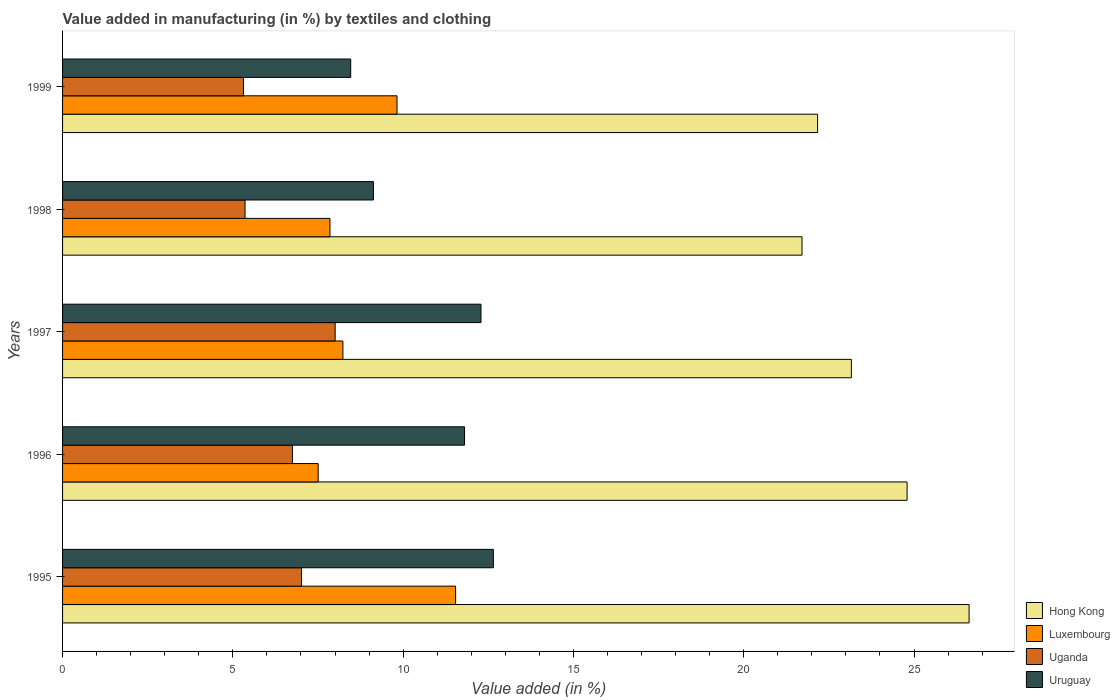How many different coloured bars are there?
Give a very brief answer. 4. Are the number of bars per tick equal to the number of legend labels?
Your answer should be compact. Yes. How many bars are there on the 1st tick from the bottom?
Provide a short and direct response. 4. What is the percentage of value added in manufacturing by textiles and clothing in Hong Kong in 1995?
Your response must be concise. 26.62. Across all years, what is the maximum percentage of value added in manufacturing by textiles and clothing in Uganda?
Make the answer very short. 8. Across all years, what is the minimum percentage of value added in manufacturing by textiles and clothing in Hong Kong?
Keep it short and to the point. 21.71. What is the total percentage of value added in manufacturing by textiles and clothing in Uruguay in the graph?
Offer a very short reply. 54.32. What is the difference between the percentage of value added in manufacturing by textiles and clothing in Uruguay in 1998 and that in 1999?
Provide a succinct answer. 0.67. What is the difference between the percentage of value added in manufacturing by textiles and clothing in Uganda in 1995 and the percentage of value added in manufacturing by textiles and clothing in Uruguay in 1999?
Provide a succinct answer. -1.45. What is the average percentage of value added in manufacturing by textiles and clothing in Uganda per year?
Offer a terse response. 6.49. In the year 1997, what is the difference between the percentage of value added in manufacturing by textiles and clothing in Uruguay and percentage of value added in manufacturing by textiles and clothing in Uganda?
Make the answer very short. 4.28. In how many years, is the percentage of value added in manufacturing by textiles and clothing in Uganda greater than 11 %?
Provide a short and direct response. 0. What is the ratio of the percentage of value added in manufacturing by textiles and clothing in Uganda in 1997 to that in 1998?
Ensure brevity in your answer.  1.49. Is the percentage of value added in manufacturing by textiles and clothing in Hong Kong in 1997 less than that in 1998?
Your answer should be very brief. No. Is the difference between the percentage of value added in manufacturing by textiles and clothing in Uruguay in 1998 and 1999 greater than the difference between the percentage of value added in manufacturing by textiles and clothing in Uganda in 1998 and 1999?
Give a very brief answer. Yes. What is the difference between the highest and the second highest percentage of value added in manufacturing by textiles and clothing in Luxembourg?
Your response must be concise. 1.72. What is the difference between the highest and the lowest percentage of value added in manufacturing by textiles and clothing in Uruguay?
Offer a terse response. 4.19. In how many years, is the percentage of value added in manufacturing by textiles and clothing in Uruguay greater than the average percentage of value added in manufacturing by textiles and clothing in Uruguay taken over all years?
Your answer should be compact. 3. Is it the case that in every year, the sum of the percentage of value added in manufacturing by textiles and clothing in Uruguay and percentage of value added in manufacturing by textiles and clothing in Luxembourg is greater than the sum of percentage of value added in manufacturing by textiles and clothing in Hong Kong and percentage of value added in manufacturing by textiles and clothing in Uganda?
Your answer should be very brief. Yes. What does the 3rd bar from the top in 1999 represents?
Ensure brevity in your answer.  Luxembourg. What does the 2nd bar from the bottom in 1999 represents?
Keep it short and to the point. Luxembourg. Is it the case that in every year, the sum of the percentage of value added in manufacturing by textiles and clothing in Hong Kong and percentage of value added in manufacturing by textiles and clothing in Uruguay is greater than the percentage of value added in manufacturing by textiles and clothing in Luxembourg?
Your response must be concise. Yes. How many years are there in the graph?
Offer a terse response. 5. Are the values on the major ticks of X-axis written in scientific E-notation?
Make the answer very short. No. Does the graph contain any zero values?
Offer a very short reply. No. Does the graph contain grids?
Your response must be concise. No. Where does the legend appear in the graph?
Make the answer very short. Bottom right. How many legend labels are there?
Provide a succinct answer. 4. What is the title of the graph?
Make the answer very short. Value added in manufacturing (in %) by textiles and clothing. Does "Austria" appear as one of the legend labels in the graph?
Your response must be concise. No. What is the label or title of the X-axis?
Provide a short and direct response. Value added (in %). What is the Value added (in %) in Hong Kong in 1995?
Your answer should be very brief. 26.62. What is the Value added (in %) in Luxembourg in 1995?
Provide a succinct answer. 11.54. What is the Value added (in %) of Uganda in 1995?
Your answer should be compact. 7.02. What is the Value added (in %) in Uruguay in 1995?
Provide a short and direct response. 12.65. What is the Value added (in %) of Hong Kong in 1996?
Offer a terse response. 24.8. What is the Value added (in %) in Luxembourg in 1996?
Offer a very short reply. 7.51. What is the Value added (in %) in Uganda in 1996?
Make the answer very short. 6.75. What is the Value added (in %) in Uruguay in 1996?
Offer a very short reply. 11.8. What is the Value added (in %) in Hong Kong in 1997?
Offer a terse response. 23.16. What is the Value added (in %) in Luxembourg in 1997?
Your response must be concise. 8.23. What is the Value added (in %) of Uganda in 1997?
Your response must be concise. 8. What is the Value added (in %) of Uruguay in 1997?
Your answer should be compact. 12.29. What is the Value added (in %) in Hong Kong in 1998?
Keep it short and to the point. 21.71. What is the Value added (in %) in Luxembourg in 1998?
Ensure brevity in your answer.  7.85. What is the Value added (in %) in Uganda in 1998?
Offer a very short reply. 5.36. What is the Value added (in %) in Uruguay in 1998?
Keep it short and to the point. 9.13. What is the Value added (in %) in Hong Kong in 1999?
Your answer should be compact. 22.17. What is the Value added (in %) of Luxembourg in 1999?
Offer a very short reply. 9.82. What is the Value added (in %) in Uganda in 1999?
Make the answer very short. 5.31. What is the Value added (in %) of Uruguay in 1999?
Make the answer very short. 8.46. Across all years, what is the maximum Value added (in %) in Hong Kong?
Offer a terse response. 26.62. Across all years, what is the maximum Value added (in %) of Luxembourg?
Give a very brief answer. 11.54. Across all years, what is the maximum Value added (in %) in Uganda?
Make the answer very short. 8. Across all years, what is the maximum Value added (in %) of Uruguay?
Offer a very short reply. 12.65. Across all years, what is the minimum Value added (in %) of Hong Kong?
Ensure brevity in your answer.  21.71. Across all years, what is the minimum Value added (in %) in Luxembourg?
Provide a succinct answer. 7.51. Across all years, what is the minimum Value added (in %) of Uganda?
Your answer should be very brief. 5.31. Across all years, what is the minimum Value added (in %) of Uruguay?
Ensure brevity in your answer.  8.46. What is the total Value added (in %) in Hong Kong in the graph?
Keep it short and to the point. 118.45. What is the total Value added (in %) in Luxembourg in the graph?
Your answer should be compact. 44.95. What is the total Value added (in %) in Uganda in the graph?
Provide a succinct answer. 32.44. What is the total Value added (in %) in Uruguay in the graph?
Provide a succinct answer. 54.32. What is the difference between the Value added (in %) in Hong Kong in 1995 and that in 1996?
Give a very brief answer. 1.82. What is the difference between the Value added (in %) of Luxembourg in 1995 and that in 1996?
Give a very brief answer. 4.03. What is the difference between the Value added (in %) of Uganda in 1995 and that in 1996?
Your answer should be compact. 0.27. What is the difference between the Value added (in %) of Uruguay in 1995 and that in 1996?
Keep it short and to the point. 0.85. What is the difference between the Value added (in %) in Hong Kong in 1995 and that in 1997?
Offer a terse response. 3.46. What is the difference between the Value added (in %) of Luxembourg in 1995 and that in 1997?
Offer a terse response. 3.31. What is the difference between the Value added (in %) of Uganda in 1995 and that in 1997?
Ensure brevity in your answer.  -0.99. What is the difference between the Value added (in %) of Uruguay in 1995 and that in 1997?
Your answer should be very brief. 0.36. What is the difference between the Value added (in %) of Hong Kong in 1995 and that in 1998?
Your response must be concise. 4.91. What is the difference between the Value added (in %) of Luxembourg in 1995 and that in 1998?
Give a very brief answer. 3.69. What is the difference between the Value added (in %) of Uganda in 1995 and that in 1998?
Offer a very short reply. 1.66. What is the difference between the Value added (in %) of Uruguay in 1995 and that in 1998?
Give a very brief answer. 3.52. What is the difference between the Value added (in %) in Hong Kong in 1995 and that in 1999?
Ensure brevity in your answer.  4.45. What is the difference between the Value added (in %) in Luxembourg in 1995 and that in 1999?
Ensure brevity in your answer.  1.72. What is the difference between the Value added (in %) of Uganda in 1995 and that in 1999?
Your answer should be very brief. 1.7. What is the difference between the Value added (in %) of Uruguay in 1995 and that in 1999?
Provide a short and direct response. 4.19. What is the difference between the Value added (in %) of Hong Kong in 1996 and that in 1997?
Offer a very short reply. 1.64. What is the difference between the Value added (in %) of Luxembourg in 1996 and that in 1997?
Offer a terse response. -0.73. What is the difference between the Value added (in %) of Uganda in 1996 and that in 1997?
Your response must be concise. -1.25. What is the difference between the Value added (in %) in Uruguay in 1996 and that in 1997?
Provide a short and direct response. -0.48. What is the difference between the Value added (in %) of Hong Kong in 1996 and that in 1998?
Give a very brief answer. 3.08. What is the difference between the Value added (in %) of Luxembourg in 1996 and that in 1998?
Offer a very short reply. -0.35. What is the difference between the Value added (in %) in Uganda in 1996 and that in 1998?
Your answer should be compact. 1.39. What is the difference between the Value added (in %) of Uruguay in 1996 and that in 1998?
Provide a succinct answer. 2.68. What is the difference between the Value added (in %) in Hong Kong in 1996 and that in 1999?
Provide a succinct answer. 2.63. What is the difference between the Value added (in %) in Luxembourg in 1996 and that in 1999?
Make the answer very short. -2.31. What is the difference between the Value added (in %) in Uganda in 1996 and that in 1999?
Your response must be concise. 1.44. What is the difference between the Value added (in %) of Uruguay in 1996 and that in 1999?
Offer a terse response. 3.34. What is the difference between the Value added (in %) of Hong Kong in 1997 and that in 1998?
Provide a succinct answer. 1.45. What is the difference between the Value added (in %) of Luxembourg in 1997 and that in 1998?
Your response must be concise. 0.38. What is the difference between the Value added (in %) in Uganda in 1997 and that in 1998?
Keep it short and to the point. 2.65. What is the difference between the Value added (in %) in Uruguay in 1997 and that in 1998?
Your answer should be very brief. 3.16. What is the difference between the Value added (in %) of Luxembourg in 1997 and that in 1999?
Provide a succinct answer. -1.59. What is the difference between the Value added (in %) in Uganda in 1997 and that in 1999?
Ensure brevity in your answer.  2.69. What is the difference between the Value added (in %) of Uruguay in 1997 and that in 1999?
Your response must be concise. 3.83. What is the difference between the Value added (in %) of Hong Kong in 1998 and that in 1999?
Give a very brief answer. -0.46. What is the difference between the Value added (in %) of Luxembourg in 1998 and that in 1999?
Keep it short and to the point. -1.97. What is the difference between the Value added (in %) in Uganda in 1998 and that in 1999?
Provide a succinct answer. 0.05. What is the difference between the Value added (in %) of Uruguay in 1998 and that in 1999?
Make the answer very short. 0.67. What is the difference between the Value added (in %) of Hong Kong in 1995 and the Value added (in %) of Luxembourg in 1996?
Provide a short and direct response. 19.11. What is the difference between the Value added (in %) of Hong Kong in 1995 and the Value added (in %) of Uganda in 1996?
Your answer should be compact. 19.87. What is the difference between the Value added (in %) in Hong Kong in 1995 and the Value added (in %) in Uruguay in 1996?
Your response must be concise. 14.81. What is the difference between the Value added (in %) in Luxembourg in 1995 and the Value added (in %) in Uganda in 1996?
Your answer should be very brief. 4.79. What is the difference between the Value added (in %) in Luxembourg in 1995 and the Value added (in %) in Uruguay in 1996?
Your response must be concise. -0.26. What is the difference between the Value added (in %) of Uganda in 1995 and the Value added (in %) of Uruguay in 1996?
Your response must be concise. -4.79. What is the difference between the Value added (in %) of Hong Kong in 1995 and the Value added (in %) of Luxembourg in 1997?
Offer a terse response. 18.39. What is the difference between the Value added (in %) in Hong Kong in 1995 and the Value added (in %) in Uganda in 1997?
Ensure brevity in your answer.  18.61. What is the difference between the Value added (in %) of Hong Kong in 1995 and the Value added (in %) of Uruguay in 1997?
Your answer should be compact. 14.33. What is the difference between the Value added (in %) of Luxembourg in 1995 and the Value added (in %) of Uganda in 1997?
Provide a short and direct response. 3.54. What is the difference between the Value added (in %) in Luxembourg in 1995 and the Value added (in %) in Uruguay in 1997?
Provide a succinct answer. -0.75. What is the difference between the Value added (in %) of Uganda in 1995 and the Value added (in %) of Uruguay in 1997?
Offer a very short reply. -5.27. What is the difference between the Value added (in %) of Hong Kong in 1995 and the Value added (in %) of Luxembourg in 1998?
Your answer should be compact. 18.77. What is the difference between the Value added (in %) in Hong Kong in 1995 and the Value added (in %) in Uganda in 1998?
Your response must be concise. 21.26. What is the difference between the Value added (in %) in Hong Kong in 1995 and the Value added (in %) in Uruguay in 1998?
Give a very brief answer. 17.49. What is the difference between the Value added (in %) in Luxembourg in 1995 and the Value added (in %) in Uganda in 1998?
Offer a very short reply. 6.18. What is the difference between the Value added (in %) in Luxembourg in 1995 and the Value added (in %) in Uruguay in 1998?
Your answer should be compact. 2.41. What is the difference between the Value added (in %) of Uganda in 1995 and the Value added (in %) of Uruguay in 1998?
Your answer should be compact. -2.11. What is the difference between the Value added (in %) of Hong Kong in 1995 and the Value added (in %) of Luxembourg in 1999?
Make the answer very short. 16.8. What is the difference between the Value added (in %) in Hong Kong in 1995 and the Value added (in %) in Uganda in 1999?
Provide a succinct answer. 21.3. What is the difference between the Value added (in %) of Hong Kong in 1995 and the Value added (in %) of Uruguay in 1999?
Ensure brevity in your answer.  18.16. What is the difference between the Value added (in %) of Luxembourg in 1995 and the Value added (in %) of Uganda in 1999?
Provide a short and direct response. 6.23. What is the difference between the Value added (in %) of Luxembourg in 1995 and the Value added (in %) of Uruguay in 1999?
Give a very brief answer. 3.08. What is the difference between the Value added (in %) of Uganda in 1995 and the Value added (in %) of Uruguay in 1999?
Make the answer very short. -1.45. What is the difference between the Value added (in %) in Hong Kong in 1996 and the Value added (in %) in Luxembourg in 1997?
Provide a succinct answer. 16.56. What is the difference between the Value added (in %) in Hong Kong in 1996 and the Value added (in %) in Uganda in 1997?
Provide a short and direct response. 16.79. What is the difference between the Value added (in %) of Hong Kong in 1996 and the Value added (in %) of Uruguay in 1997?
Keep it short and to the point. 12.51. What is the difference between the Value added (in %) in Luxembourg in 1996 and the Value added (in %) in Uganda in 1997?
Offer a very short reply. -0.5. What is the difference between the Value added (in %) in Luxembourg in 1996 and the Value added (in %) in Uruguay in 1997?
Offer a very short reply. -4.78. What is the difference between the Value added (in %) in Uganda in 1996 and the Value added (in %) in Uruguay in 1997?
Your answer should be very brief. -5.54. What is the difference between the Value added (in %) in Hong Kong in 1996 and the Value added (in %) in Luxembourg in 1998?
Your response must be concise. 16.94. What is the difference between the Value added (in %) of Hong Kong in 1996 and the Value added (in %) of Uganda in 1998?
Your answer should be compact. 19.44. What is the difference between the Value added (in %) in Hong Kong in 1996 and the Value added (in %) in Uruguay in 1998?
Offer a very short reply. 15.67. What is the difference between the Value added (in %) in Luxembourg in 1996 and the Value added (in %) in Uganda in 1998?
Give a very brief answer. 2.15. What is the difference between the Value added (in %) in Luxembourg in 1996 and the Value added (in %) in Uruguay in 1998?
Your response must be concise. -1.62. What is the difference between the Value added (in %) in Uganda in 1996 and the Value added (in %) in Uruguay in 1998?
Your response must be concise. -2.38. What is the difference between the Value added (in %) in Hong Kong in 1996 and the Value added (in %) in Luxembourg in 1999?
Offer a terse response. 14.98. What is the difference between the Value added (in %) of Hong Kong in 1996 and the Value added (in %) of Uganda in 1999?
Your answer should be very brief. 19.48. What is the difference between the Value added (in %) in Hong Kong in 1996 and the Value added (in %) in Uruguay in 1999?
Keep it short and to the point. 16.34. What is the difference between the Value added (in %) in Luxembourg in 1996 and the Value added (in %) in Uganda in 1999?
Offer a terse response. 2.19. What is the difference between the Value added (in %) of Luxembourg in 1996 and the Value added (in %) of Uruguay in 1999?
Your response must be concise. -0.95. What is the difference between the Value added (in %) of Uganda in 1996 and the Value added (in %) of Uruguay in 1999?
Keep it short and to the point. -1.71. What is the difference between the Value added (in %) of Hong Kong in 1997 and the Value added (in %) of Luxembourg in 1998?
Your response must be concise. 15.31. What is the difference between the Value added (in %) in Hong Kong in 1997 and the Value added (in %) in Uganda in 1998?
Your response must be concise. 17.8. What is the difference between the Value added (in %) in Hong Kong in 1997 and the Value added (in %) in Uruguay in 1998?
Your answer should be compact. 14.03. What is the difference between the Value added (in %) in Luxembourg in 1997 and the Value added (in %) in Uganda in 1998?
Give a very brief answer. 2.87. What is the difference between the Value added (in %) in Luxembourg in 1997 and the Value added (in %) in Uruguay in 1998?
Ensure brevity in your answer.  -0.9. What is the difference between the Value added (in %) of Uganda in 1997 and the Value added (in %) of Uruguay in 1998?
Give a very brief answer. -1.12. What is the difference between the Value added (in %) in Hong Kong in 1997 and the Value added (in %) in Luxembourg in 1999?
Your answer should be compact. 13.34. What is the difference between the Value added (in %) of Hong Kong in 1997 and the Value added (in %) of Uganda in 1999?
Provide a short and direct response. 17.85. What is the difference between the Value added (in %) of Hong Kong in 1997 and the Value added (in %) of Uruguay in 1999?
Your response must be concise. 14.7. What is the difference between the Value added (in %) of Luxembourg in 1997 and the Value added (in %) of Uganda in 1999?
Provide a short and direct response. 2.92. What is the difference between the Value added (in %) in Luxembourg in 1997 and the Value added (in %) in Uruguay in 1999?
Give a very brief answer. -0.23. What is the difference between the Value added (in %) of Uganda in 1997 and the Value added (in %) of Uruguay in 1999?
Your response must be concise. -0.46. What is the difference between the Value added (in %) in Hong Kong in 1998 and the Value added (in %) in Luxembourg in 1999?
Your answer should be very brief. 11.89. What is the difference between the Value added (in %) in Hong Kong in 1998 and the Value added (in %) in Uganda in 1999?
Your answer should be very brief. 16.4. What is the difference between the Value added (in %) of Hong Kong in 1998 and the Value added (in %) of Uruguay in 1999?
Your response must be concise. 13.25. What is the difference between the Value added (in %) in Luxembourg in 1998 and the Value added (in %) in Uganda in 1999?
Offer a very short reply. 2.54. What is the difference between the Value added (in %) in Luxembourg in 1998 and the Value added (in %) in Uruguay in 1999?
Your response must be concise. -0.61. What is the difference between the Value added (in %) in Uganda in 1998 and the Value added (in %) in Uruguay in 1999?
Your answer should be very brief. -3.1. What is the average Value added (in %) of Hong Kong per year?
Your answer should be compact. 23.69. What is the average Value added (in %) of Luxembourg per year?
Ensure brevity in your answer.  8.99. What is the average Value added (in %) of Uganda per year?
Offer a terse response. 6.49. What is the average Value added (in %) of Uruguay per year?
Make the answer very short. 10.86. In the year 1995, what is the difference between the Value added (in %) in Hong Kong and Value added (in %) in Luxembourg?
Offer a very short reply. 15.08. In the year 1995, what is the difference between the Value added (in %) of Hong Kong and Value added (in %) of Uganda?
Provide a short and direct response. 19.6. In the year 1995, what is the difference between the Value added (in %) in Hong Kong and Value added (in %) in Uruguay?
Keep it short and to the point. 13.97. In the year 1995, what is the difference between the Value added (in %) in Luxembourg and Value added (in %) in Uganda?
Your answer should be compact. 4.52. In the year 1995, what is the difference between the Value added (in %) of Luxembourg and Value added (in %) of Uruguay?
Keep it short and to the point. -1.11. In the year 1995, what is the difference between the Value added (in %) in Uganda and Value added (in %) in Uruguay?
Offer a terse response. -5.63. In the year 1996, what is the difference between the Value added (in %) in Hong Kong and Value added (in %) in Luxembourg?
Give a very brief answer. 17.29. In the year 1996, what is the difference between the Value added (in %) in Hong Kong and Value added (in %) in Uganda?
Your response must be concise. 18.05. In the year 1996, what is the difference between the Value added (in %) of Hong Kong and Value added (in %) of Uruguay?
Your answer should be very brief. 12.99. In the year 1996, what is the difference between the Value added (in %) in Luxembourg and Value added (in %) in Uganda?
Your response must be concise. 0.76. In the year 1996, what is the difference between the Value added (in %) in Luxembourg and Value added (in %) in Uruguay?
Ensure brevity in your answer.  -4.3. In the year 1996, what is the difference between the Value added (in %) in Uganda and Value added (in %) in Uruguay?
Offer a very short reply. -5.05. In the year 1997, what is the difference between the Value added (in %) in Hong Kong and Value added (in %) in Luxembourg?
Your answer should be very brief. 14.93. In the year 1997, what is the difference between the Value added (in %) of Hong Kong and Value added (in %) of Uganda?
Offer a very short reply. 15.16. In the year 1997, what is the difference between the Value added (in %) of Hong Kong and Value added (in %) of Uruguay?
Your answer should be compact. 10.87. In the year 1997, what is the difference between the Value added (in %) in Luxembourg and Value added (in %) in Uganda?
Offer a terse response. 0.23. In the year 1997, what is the difference between the Value added (in %) in Luxembourg and Value added (in %) in Uruguay?
Keep it short and to the point. -4.05. In the year 1997, what is the difference between the Value added (in %) of Uganda and Value added (in %) of Uruguay?
Give a very brief answer. -4.28. In the year 1998, what is the difference between the Value added (in %) of Hong Kong and Value added (in %) of Luxembourg?
Your response must be concise. 13.86. In the year 1998, what is the difference between the Value added (in %) of Hong Kong and Value added (in %) of Uganda?
Offer a terse response. 16.35. In the year 1998, what is the difference between the Value added (in %) in Hong Kong and Value added (in %) in Uruguay?
Ensure brevity in your answer.  12.58. In the year 1998, what is the difference between the Value added (in %) in Luxembourg and Value added (in %) in Uganda?
Offer a terse response. 2.49. In the year 1998, what is the difference between the Value added (in %) in Luxembourg and Value added (in %) in Uruguay?
Offer a very short reply. -1.28. In the year 1998, what is the difference between the Value added (in %) of Uganda and Value added (in %) of Uruguay?
Provide a short and direct response. -3.77. In the year 1999, what is the difference between the Value added (in %) of Hong Kong and Value added (in %) of Luxembourg?
Ensure brevity in your answer.  12.35. In the year 1999, what is the difference between the Value added (in %) of Hong Kong and Value added (in %) of Uganda?
Ensure brevity in your answer.  16.86. In the year 1999, what is the difference between the Value added (in %) in Hong Kong and Value added (in %) in Uruguay?
Offer a terse response. 13.71. In the year 1999, what is the difference between the Value added (in %) in Luxembourg and Value added (in %) in Uganda?
Provide a succinct answer. 4.51. In the year 1999, what is the difference between the Value added (in %) in Luxembourg and Value added (in %) in Uruguay?
Give a very brief answer. 1.36. In the year 1999, what is the difference between the Value added (in %) in Uganda and Value added (in %) in Uruguay?
Offer a terse response. -3.15. What is the ratio of the Value added (in %) in Hong Kong in 1995 to that in 1996?
Give a very brief answer. 1.07. What is the ratio of the Value added (in %) in Luxembourg in 1995 to that in 1996?
Provide a succinct answer. 1.54. What is the ratio of the Value added (in %) in Uganda in 1995 to that in 1996?
Provide a short and direct response. 1.04. What is the ratio of the Value added (in %) in Uruguay in 1995 to that in 1996?
Offer a terse response. 1.07. What is the ratio of the Value added (in %) of Hong Kong in 1995 to that in 1997?
Offer a terse response. 1.15. What is the ratio of the Value added (in %) in Luxembourg in 1995 to that in 1997?
Give a very brief answer. 1.4. What is the ratio of the Value added (in %) of Uganda in 1995 to that in 1997?
Provide a short and direct response. 0.88. What is the ratio of the Value added (in %) of Uruguay in 1995 to that in 1997?
Ensure brevity in your answer.  1.03. What is the ratio of the Value added (in %) of Hong Kong in 1995 to that in 1998?
Provide a short and direct response. 1.23. What is the ratio of the Value added (in %) in Luxembourg in 1995 to that in 1998?
Provide a short and direct response. 1.47. What is the ratio of the Value added (in %) of Uganda in 1995 to that in 1998?
Offer a terse response. 1.31. What is the ratio of the Value added (in %) of Uruguay in 1995 to that in 1998?
Provide a short and direct response. 1.39. What is the ratio of the Value added (in %) of Hong Kong in 1995 to that in 1999?
Make the answer very short. 1.2. What is the ratio of the Value added (in %) of Luxembourg in 1995 to that in 1999?
Give a very brief answer. 1.18. What is the ratio of the Value added (in %) in Uganda in 1995 to that in 1999?
Your response must be concise. 1.32. What is the ratio of the Value added (in %) in Uruguay in 1995 to that in 1999?
Offer a terse response. 1.5. What is the ratio of the Value added (in %) in Hong Kong in 1996 to that in 1997?
Your answer should be compact. 1.07. What is the ratio of the Value added (in %) of Luxembourg in 1996 to that in 1997?
Provide a succinct answer. 0.91. What is the ratio of the Value added (in %) of Uganda in 1996 to that in 1997?
Offer a terse response. 0.84. What is the ratio of the Value added (in %) in Uruguay in 1996 to that in 1997?
Provide a short and direct response. 0.96. What is the ratio of the Value added (in %) of Hong Kong in 1996 to that in 1998?
Your answer should be very brief. 1.14. What is the ratio of the Value added (in %) in Luxembourg in 1996 to that in 1998?
Make the answer very short. 0.96. What is the ratio of the Value added (in %) of Uganda in 1996 to that in 1998?
Your response must be concise. 1.26. What is the ratio of the Value added (in %) of Uruguay in 1996 to that in 1998?
Your response must be concise. 1.29. What is the ratio of the Value added (in %) in Hong Kong in 1996 to that in 1999?
Offer a terse response. 1.12. What is the ratio of the Value added (in %) in Luxembourg in 1996 to that in 1999?
Ensure brevity in your answer.  0.76. What is the ratio of the Value added (in %) of Uganda in 1996 to that in 1999?
Keep it short and to the point. 1.27. What is the ratio of the Value added (in %) of Uruguay in 1996 to that in 1999?
Offer a terse response. 1.4. What is the ratio of the Value added (in %) of Hong Kong in 1997 to that in 1998?
Provide a succinct answer. 1.07. What is the ratio of the Value added (in %) in Luxembourg in 1997 to that in 1998?
Give a very brief answer. 1.05. What is the ratio of the Value added (in %) in Uganda in 1997 to that in 1998?
Make the answer very short. 1.49. What is the ratio of the Value added (in %) in Uruguay in 1997 to that in 1998?
Your answer should be very brief. 1.35. What is the ratio of the Value added (in %) in Hong Kong in 1997 to that in 1999?
Offer a very short reply. 1.04. What is the ratio of the Value added (in %) of Luxembourg in 1997 to that in 1999?
Your answer should be compact. 0.84. What is the ratio of the Value added (in %) in Uganda in 1997 to that in 1999?
Offer a terse response. 1.51. What is the ratio of the Value added (in %) in Uruguay in 1997 to that in 1999?
Your answer should be compact. 1.45. What is the ratio of the Value added (in %) in Hong Kong in 1998 to that in 1999?
Provide a short and direct response. 0.98. What is the ratio of the Value added (in %) of Luxembourg in 1998 to that in 1999?
Ensure brevity in your answer.  0.8. What is the ratio of the Value added (in %) in Uganda in 1998 to that in 1999?
Offer a very short reply. 1.01. What is the ratio of the Value added (in %) in Uruguay in 1998 to that in 1999?
Your answer should be compact. 1.08. What is the difference between the highest and the second highest Value added (in %) in Hong Kong?
Offer a very short reply. 1.82. What is the difference between the highest and the second highest Value added (in %) in Luxembourg?
Keep it short and to the point. 1.72. What is the difference between the highest and the second highest Value added (in %) of Uruguay?
Keep it short and to the point. 0.36. What is the difference between the highest and the lowest Value added (in %) in Hong Kong?
Give a very brief answer. 4.91. What is the difference between the highest and the lowest Value added (in %) in Luxembourg?
Give a very brief answer. 4.03. What is the difference between the highest and the lowest Value added (in %) of Uganda?
Your answer should be very brief. 2.69. What is the difference between the highest and the lowest Value added (in %) of Uruguay?
Provide a succinct answer. 4.19. 